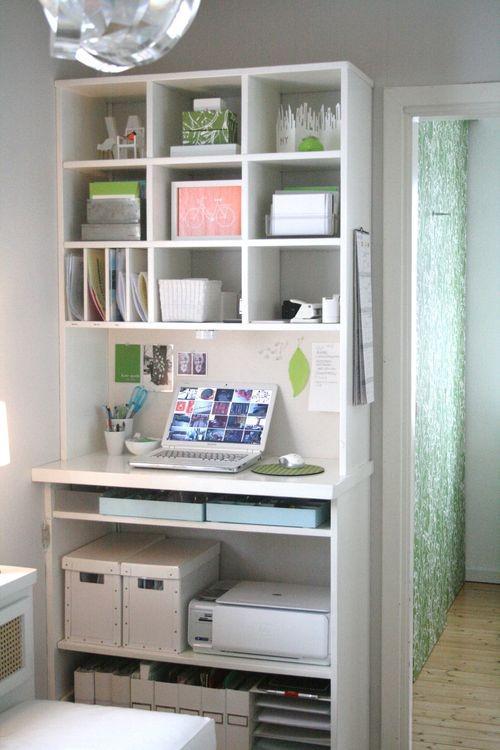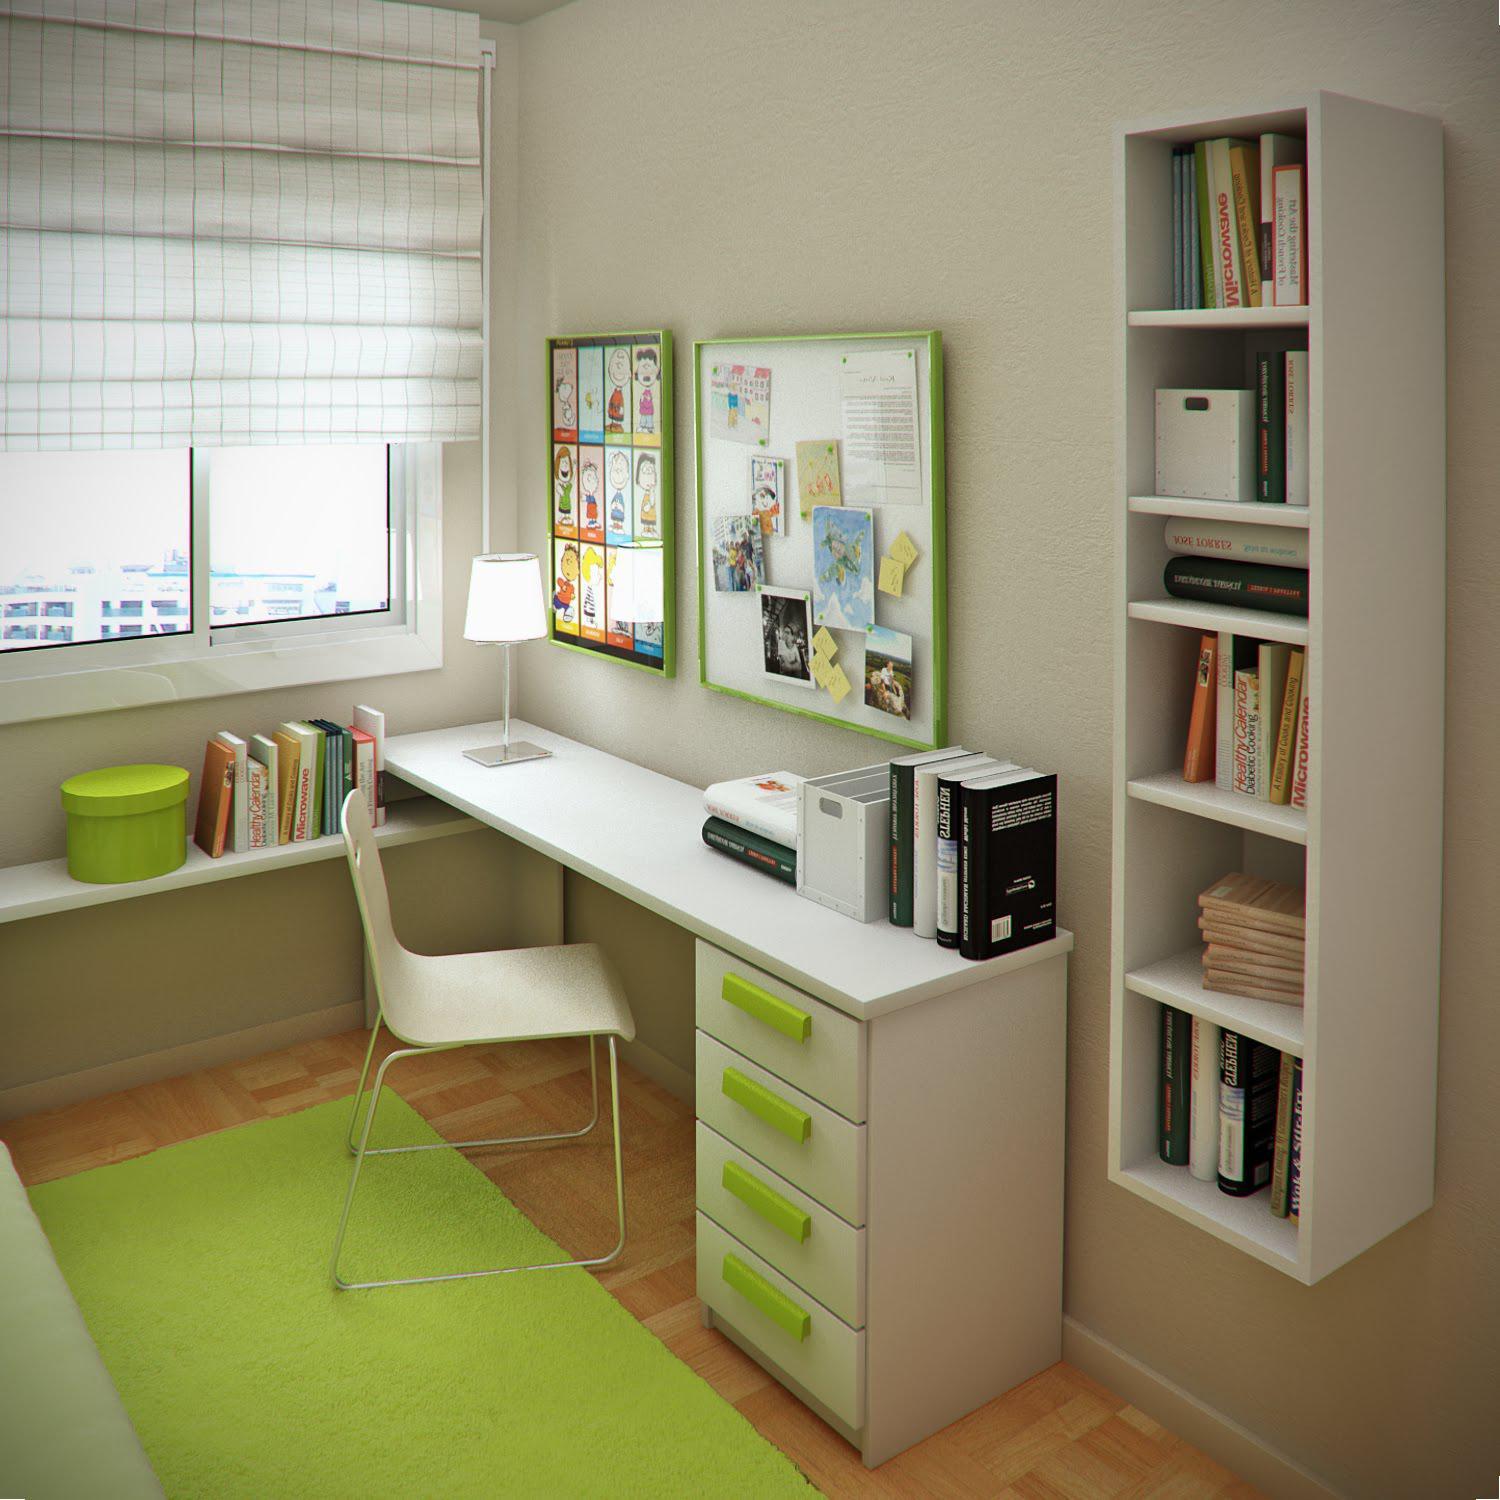The first image is the image on the left, the second image is the image on the right. Considering the images on both sides, is "In one of the images, the desk chair is white." valid? Answer yes or no. Yes. The first image is the image on the left, the second image is the image on the right. Evaluate the accuracy of this statement regarding the images: "Both desks have a computer or monitor visible.". Is it true? Answer yes or no. No. 